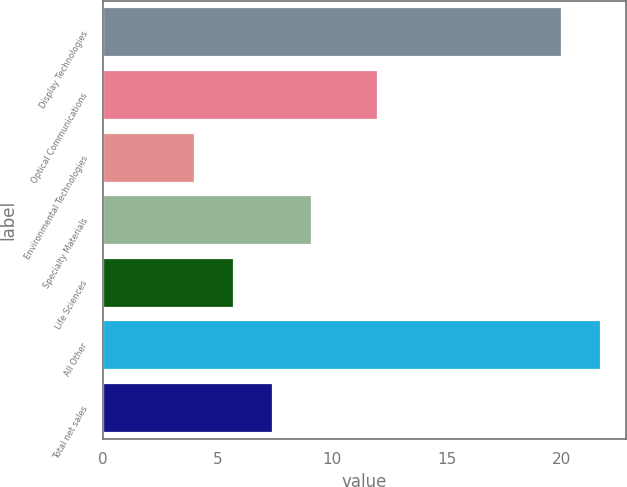<chart> <loc_0><loc_0><loc_500><loc_500><bar_chart><fcel>Display Technologies<fcel>Optical Communications<fcel>Environmental Technologies<fcel>Specialty Materials<fcel>Life Sciences<fcel>All Other<fcel>Total net sales<nl><fcel>20<fcel>12<fcel>4<fcel>9.1<fcel>5.7<fcel>21.7<fcel>7.4<nl></chart> 